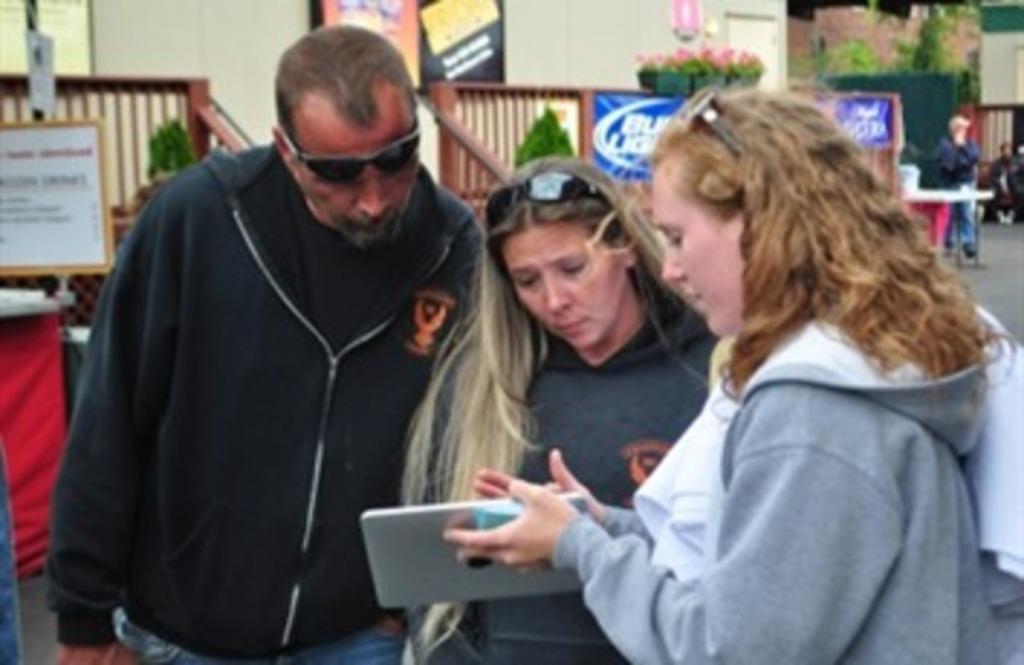Could you give a brief overview of what you see in this image? In this image we can see two women and one man are standing. One woman is holding an electronic device in her hand. In the background, we can see trailing, potted plants and frames on the wall. On the left side of the image, we can see a board and an object. On the right side of the image, we can see people and road. 